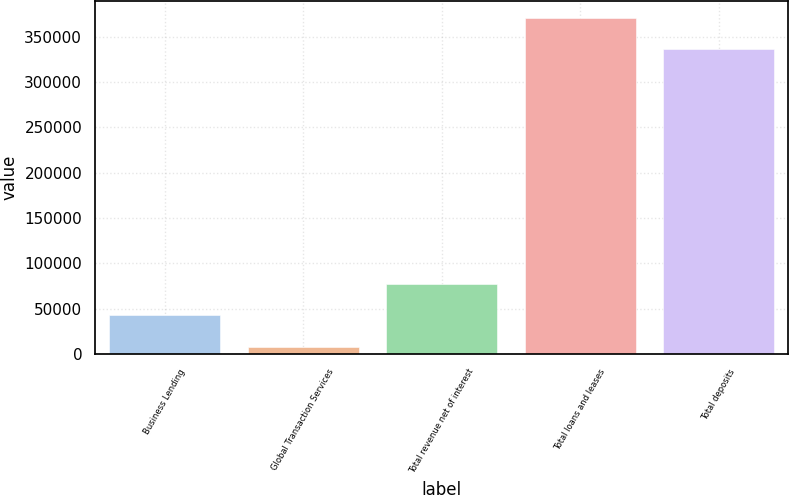<chart> <loc_0><loc_0><loc_500><loc_500><bar_chart><fcel>Business Lending<fcel>Global Transaction Services<fcel>Total revenue net of interest<fcel>Total loans and leases<fcel>Total deposits<nl><fcel>42548<fcel>7917<fcel>77179<fcel>370989<fcel>336358<nl></chart> 